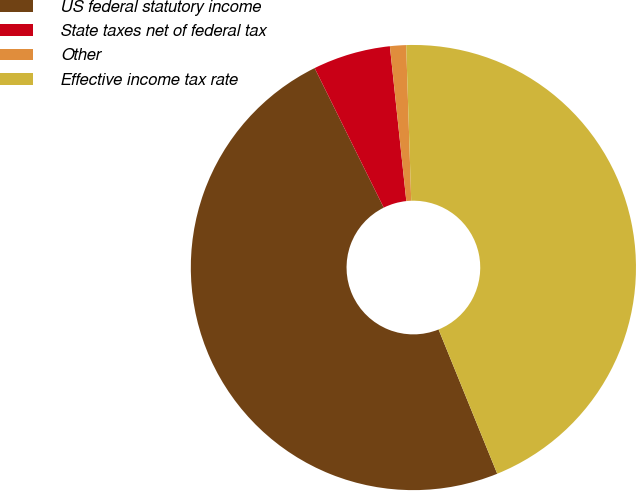Convert chart. <chart><loc_0><loc_0><loc_500><loc_500><pie_chart><fcel>US federal statutory income<fcel>State taxes net of federal tax<fcel>Other<fcel>Effective income tax rate<nl><fcel>48.83%<fcel>5.63%<fcel>1.17%<fcel>44.37%<nl></chart> 